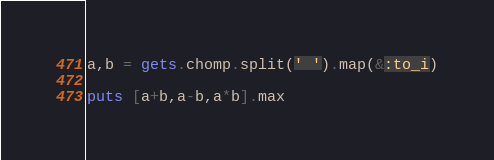Convert code to text. <code><loc_0><loc_0><loc_500><loc_500><_Ruby_>a,b = gets.chomp.split(' ').map(&:to_i)

puts [a+b,a-b,a*b].max</code> 